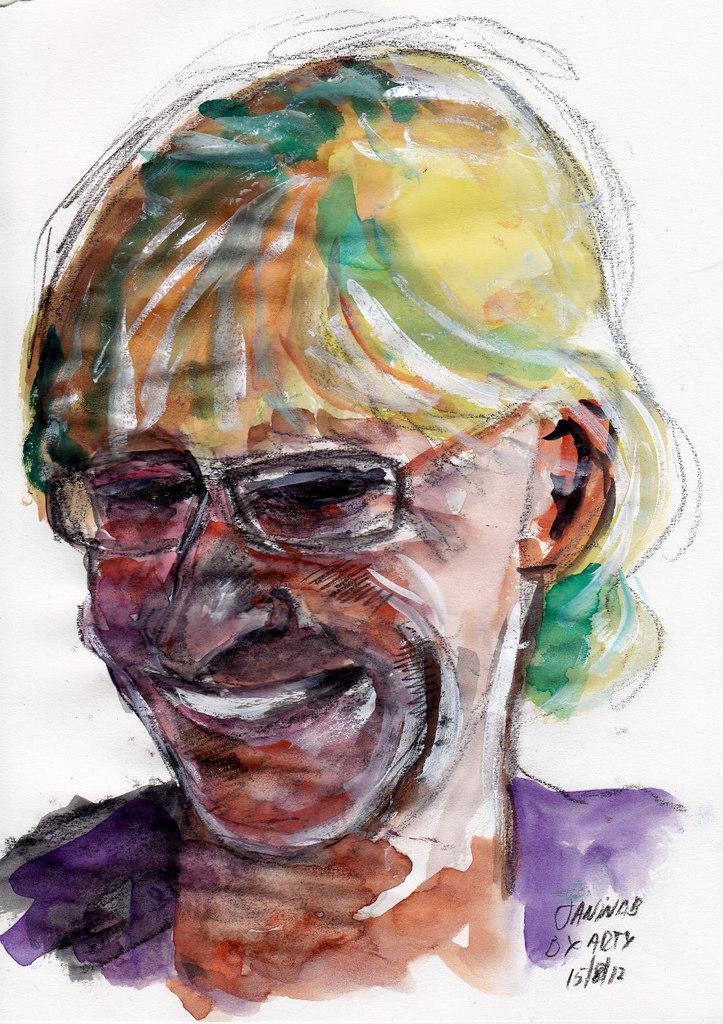Describe this image in one or two sentences. This is a painting. Here we can see face of a person and there is a white background. 